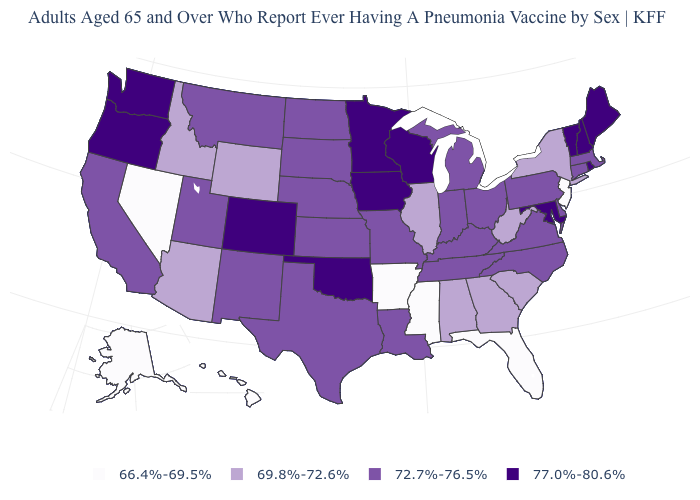What is the value of Massachusetts?
Be succinct. 72.7%-76.5%. How many symbols are there in the legend?
Answer briefly. 4. What is the value of Colorado?
Short answer required. 77.0%-80.6%. Name the states that have a value in the range 66.4%-69.5%?
Keep it brief. Alaska, Arkansas, Florida, Hawaii, Mississippi, Nevada, New Jersey. Among the states that border Massachusetts , does Vermont have the lowest value?
Write a very short answer. No. Does Alaska have the lowest value in the USA?
Concise answer only. Yes. What is the highest value in the USA?
Be succinct. 77.0%-80.6%. Does the map have missing data?
Keep it brief. No. Name the states that have a value in the range 72.7%-76.5%?
Write a very short answer. California, Connecticut, Delaware, Indiana, Kansas, Kentucky, Louisiana, Massachusetts, Michigan, Missouri, Montana, Nebraska, New Mexico, North Carolina, North Dakota, Ohio, Pennsylvania, South Dakota, Tennessee, Texas, Utah, Virginia. What is the highest value in states that border Nebraska?
Concise answer only. 77.0%-80.6%. What is the highest value in the West ?
Be succinct. 77.0%-80.6%. What is the value of Hawaii?
Give a very brief answer. 66.4%-69.5%. Which states have the lowest value in the South?
Quick response, please. Arkansas, Florida, Mississippi. Does the first symbol in the legend represent the smallest category?
Be succinct. Yes. Among the states that border Oregon , does Washington have the lowest value?
Be succinct. No. 